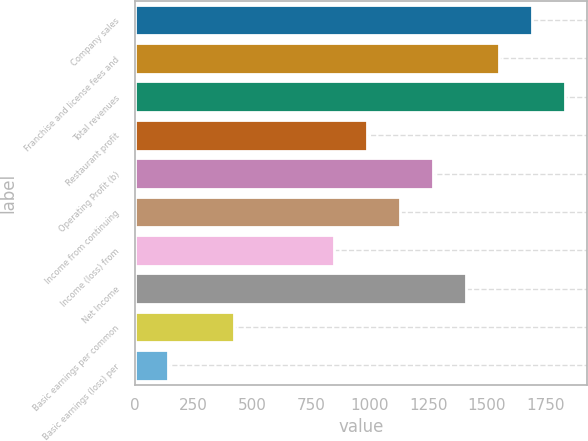<chart> <loc_0><loc_0><loc_500><loc_500><bar_chart><fcel>Company sales<fcel>Franchise and license fees and<fcel>Total revenues<fcel>Restaurant profit<fcel>Operating Profit (b)<fcel>Income from continuing<fcel>Income (loss) from<fcel>Net Income<fcel>Basic earnings per common<fcel>Basic earnings (loss) per<nl><fcel>1693.1<fcel>1552.03<fcel>1834.17<fcel>987.75<fcel>1269.89<fcel>1128.82<fcel>846.68<fcel>1410.96<fcel>423.47<fcel>141.33<nl></chart> 